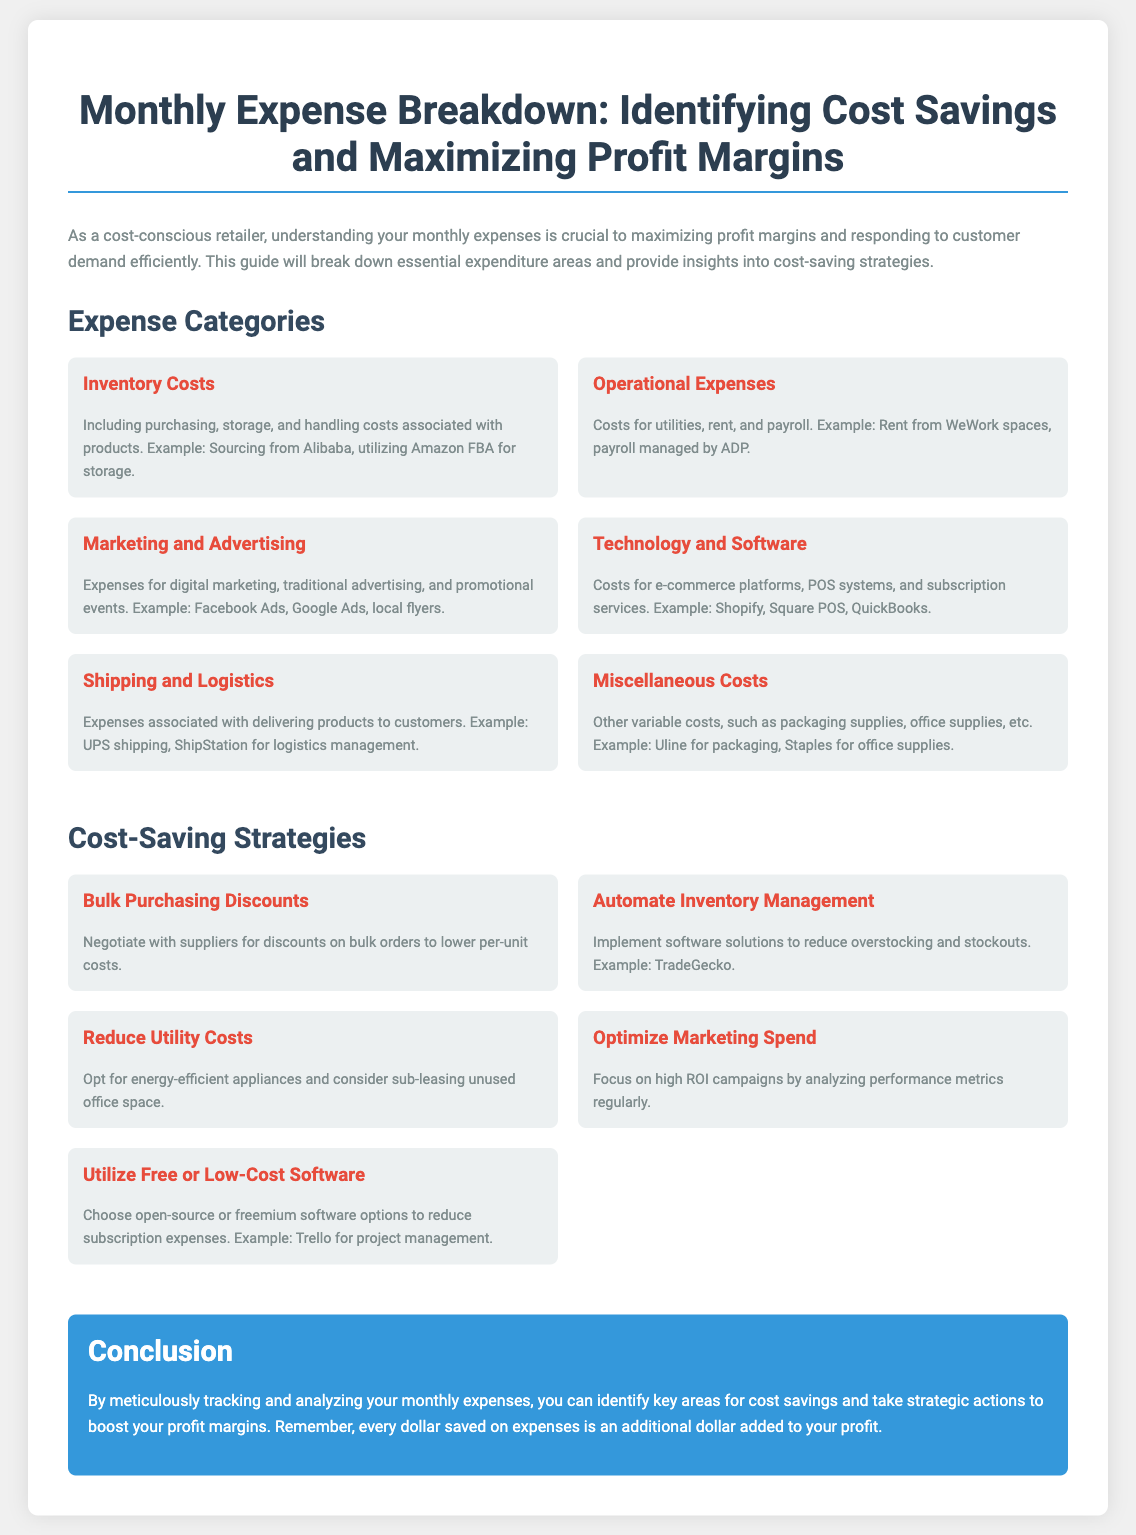What is the title of the poster? The title of the poster is the main heading that summarizes the content and focus of the document.
Answer: Monthly Expense Breakdown: Identifying Cost Savings and Maximizing Profit Margins What is included in Inventory Costs? Inventory Costs encompass significant expenditures related to the products of a retailer, detailing various cost elements.
Answer: Purchasing, storage, and handling costs Which software is suggested for project management? The document provides examples of software that can assist with specific business functions, including project management solutions.
Answer: Trello What category includes costs for utilities and rent? Various expense categories are mentioned, and one specifically encompasses operational costs, detailing utility and rent-related expenses.
Answer: Operational Expenses What strategy suggests negotiating with suppliers? The document presents several strategies for cost savings, one of which emphasizes the importance of supplier negotiations for bulk purchases.
Answer: Bulk Purchasing Discounts What is one way to reduce utility costs? The document provides actionable recommendations for reducing expenses, one of which is focused on energy efficiency.
Answer: Opt for energy-efficient appliances How many cost-saving strategies are listed? The number of strategies presented in the document indicates the breadth of cost-saving opportunities for retailers.
Answer: Five strategies What should you focus on to optimize marketing spend? The document advises attention to a particular aspect of marketing efforts to ensure effective spending and resource allocation.
Answer: High ROI campaigns 